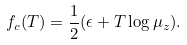Convert formula to latex. <formula><loc_0><loc_0><loc_500><loc_500>f _ { c } ( T ) = \frac { 1 } { 2 } ( \epsilon + T \log { \mu _ { z } } ) .</formula> 